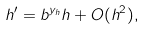<formula> <loc_0><loc_0><loc_500><loc_500>h ^ { \prime } = b ^ { y _ { h } } h + O ( h ^ { 2 } ) ,</formula> 